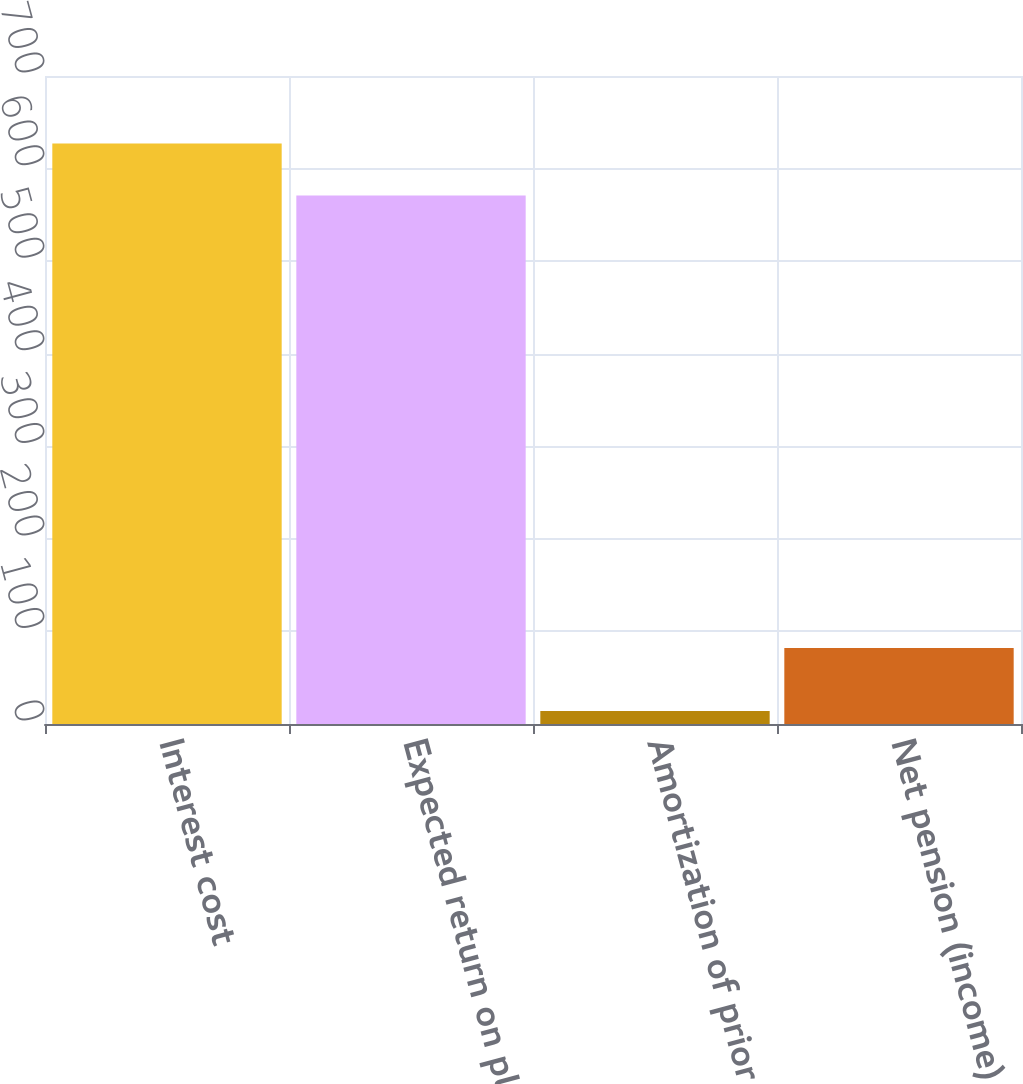<chart> <loc_0><loc_0><loc_500><loc_500><bar_chart><fcel>Interest cost<fcel>Expected return on plan assets<fcel>Amortization of prior service<fcel>Net pension (income) expense<nl><fcel>627.2<fcel>571<fcel>14<fcel>82<nl></chart> 